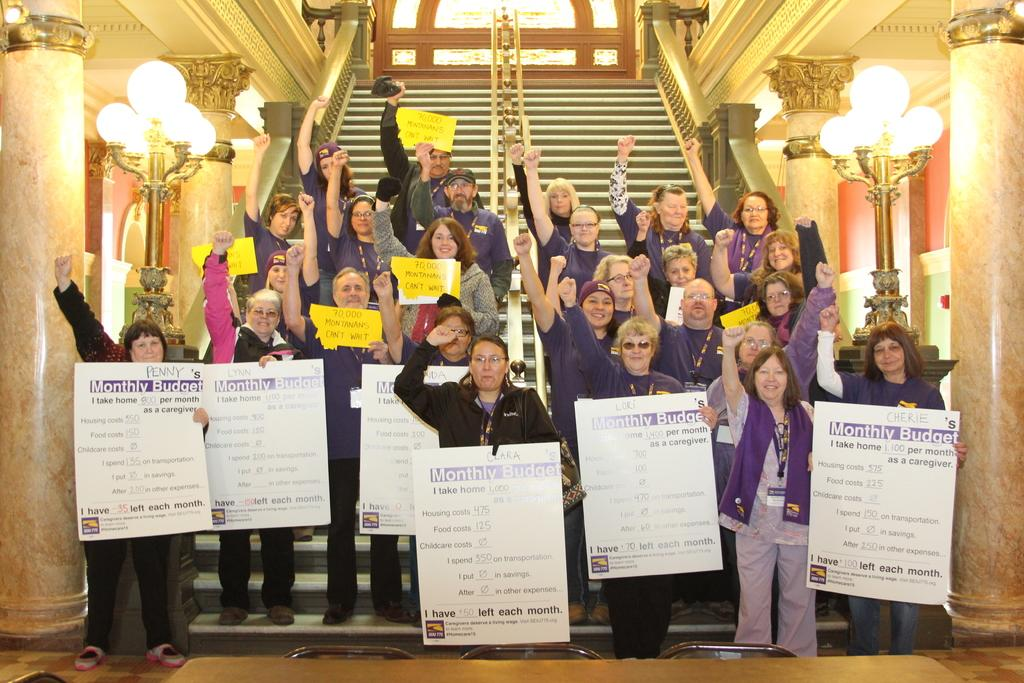What is the main subject of the image? The main subject of the image is a group of people. Where are the people located in the image? The people are standing on a staircase in the image. What are the people holding in their hands? The people are holding boards in their hands. What can be seen on either side of the image? There are lights on either side of the image. Can you tell me what hobbies the people are discussing while standing on the staircase? The image does not provide information about the people's hobbies or any discussions they might be having. 